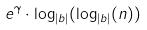<formula> <loc_0><loc_0><loc_500><loc_500>e ^ { \gamma } \cdot \log _ { | b | } ( \log _ { | b | } ( n ) )</formula> 